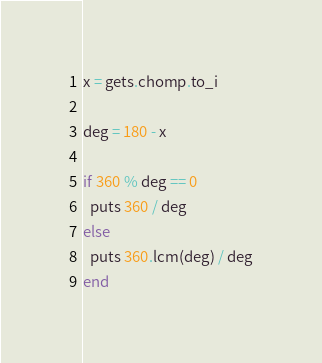<code> <loc_0><loc_0><loc_500><loc_500><_Ruby_>x = gets.chomp.to_i

deg = 180 - x

if 360 % deg == 0
  puts 360 / deg
else
  puts 360.lcm(deg) / deg
end
</code> 